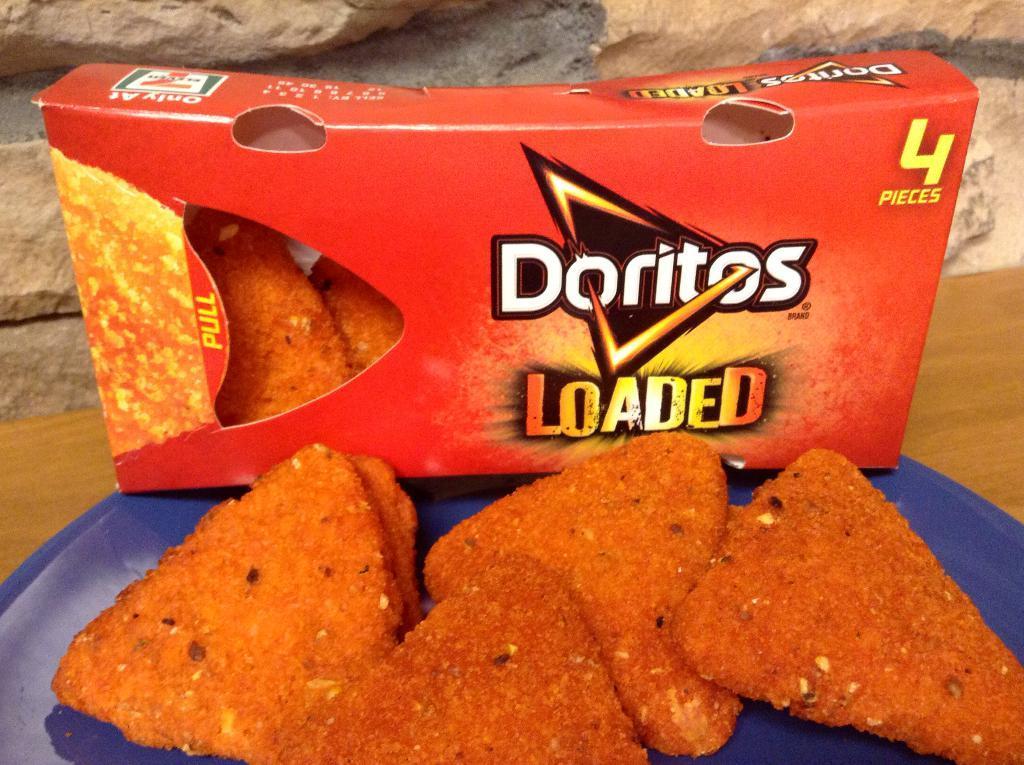In one or two sentences, can you explain what this image depicts? Here in this picture we can see a table, on which we can see Doritos present on a plate over there and we can also see a box of Doritos present over there and behind that we can see rock stones present over there. 